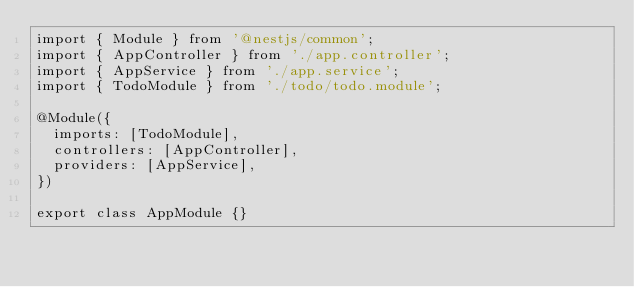Convert code to text. <code><loc_0><loc_0><loc_500><loc_500><_TypeScript_>import { Module } from '@nestjs/common';
import { AppController } from './app.controller';
import { AppService } from './app.service';
import { TodoModule } from './todo/todo.module';

@Module({
  imports: [TodoModule],
  controllers: [AppController],
  providers: [AppService],
})

export class AppModule {}
</code> 